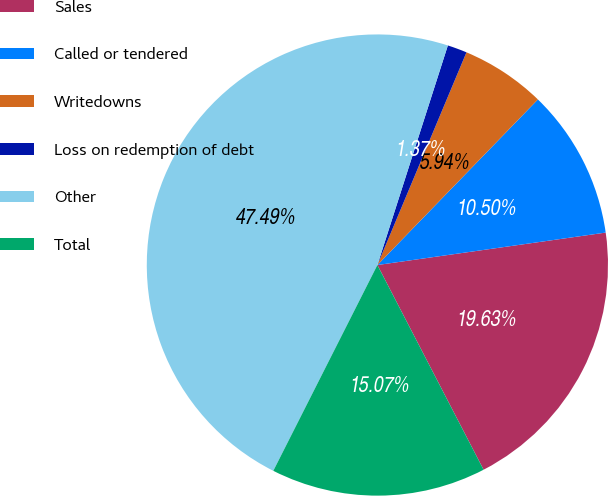Convert chart. <chart><loc_0><loc_0><loc_500><loc_500><pie_chart><fcel>Sales<fcel>Called or tendered<fcel>Writedowns<fcel>Loss on redemption of debt<fcel>Other<fcel>Total<nl><fcel>19.63%<fcel>10.5%<fcel>5.94%<fcel>1.37%<fcel>47.49%<fcel>15.07%<nl></chart> 